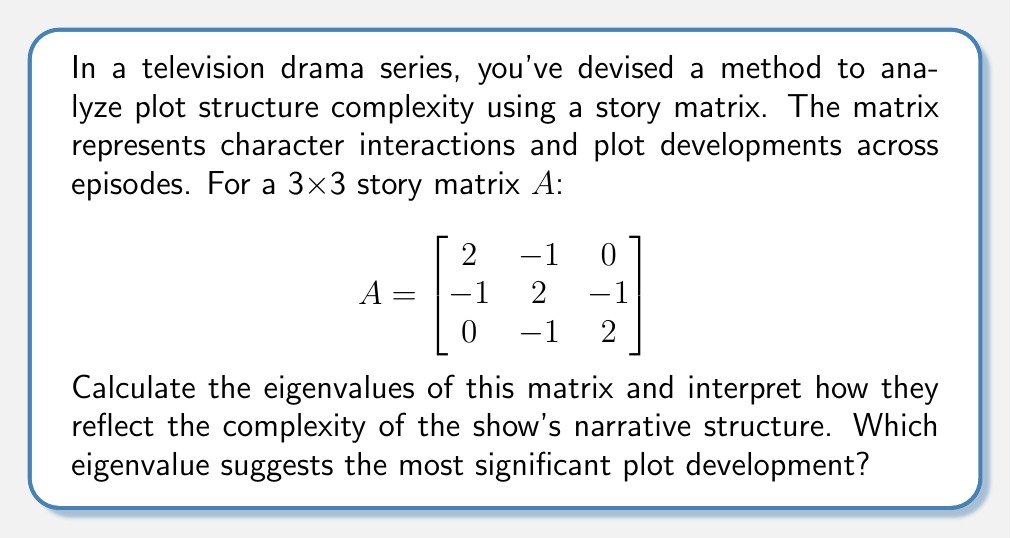Could you help me with this problem? To analyze the plot structure complexity using eigenvalues, we'll follow these steps:

1) First, we need to find the characteristic equation of the matrix A:
   $det(A - \lambda I) = 0$

2) Expand the determinant:
   $$ \begin{vmatrix}
   2-\lambda & -1 & 0 \\
   -1 & 2-\lambda & -1 \\
   0 & -1 & 2-\lambda
   \end{vmatrix} = 0 $$

3) Calculate the determinant:
   $(2-\lambda)[(2-\lambda)(2-\lambda) - 1] - (-1)[(-1)(2-\lambda) - 0] = 0$
   $(2-\lambda)[(4-4\lambda+\lambda^2) - 1] + (2-\lambda) = 0$
   $(2-\lambda)(3-4\lambda+\lambda^2) + (2-\lambda) = 0$
   $6-12\lambda+3\lambda^2-8\lambda+2\lambda^2+\lambda^3 + 2 - \lambda = 0$
   $\lambda^3 - 3\lambda^2 + 3\lambda - 1 = 0$

4) This is a cubic equation. The solutions to this equation are the eigenvalues. 
   We can factor this equation:
   $(\lambda - 1)(\lambda - 1)(\lambda - 1) = 0$

5) Therefore, the eigenvalues are:
   $\lambda_1 = \lambda_2 = \lambda_3 = 1$

Interpretation:
In the context of plot structure, eigenvalues represent the rate of change or growth in different aspects of the narrative. The fact that all eigenvalues are equal to 1 suggests a balanced and steady plot development across all narrative threads. This could indicate a consistent pacing throughout the series, with no single plotline dominating the others.

The eigenvalue of 1 is the most significant, as it's the only eigenvalue present. This suggests that the show maintains a stable narrative structure, potentially focusing on character development and gradual plot progression rather than sudden, dramatic shifts.
Answer: $\lambda_1 = \lambda_2 = \lambda_3 = 1$; balanced plot development 